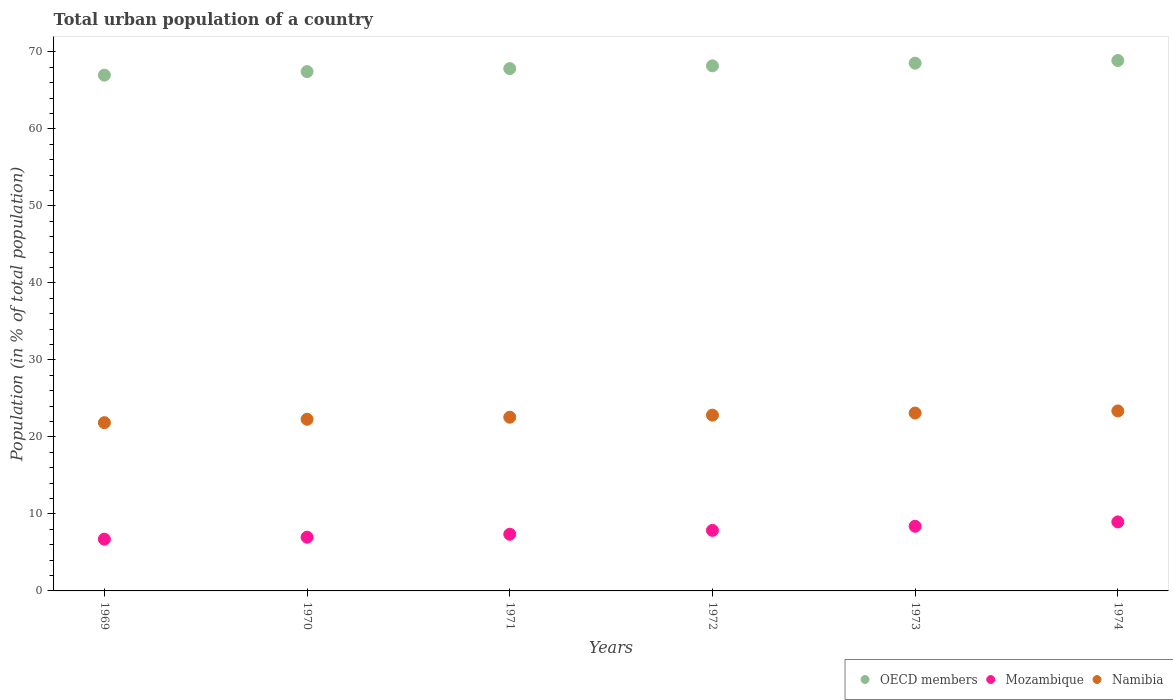How many different coloured dotlines are there?
Make the answer very short. 3. Is the number of dotlines equal to the number of legend labels?
Your answer should be compact. Yes. What is the urban population in Mozambique in 1971?
Your answer should be very brief. 7.36. Across all years, what is the maximum urban population in Namibia?
Offer a very short reply. 23.37. Across all years, what is the minimum urban population in Mozambique?
Offer a terse response. 6.72. In which year was the urban population in Namibia maximum?
Provide a succinct answer. 1974. In which year was the urban population in Namibia minimum?
Keep it short and to the point. 1969. What is the total urban population in Mozambique in the graph?
Your answer should be compact. 46.28. What is the difference between the urban population in Namibia in 1970 and that in 1974?
Offer a terse response. -1.08. What is the difference between the urban population in Mozambique in 1971 and the urban population in OECD members in 1972?
Provide a short and direct response. -60.83. What is the average urban population in OECD members per year?
Ensure brevity in your answer.  67.98. In the year 1974, what is the difference between the urban population in OECD members and urban population in Namibia?
Provide a short and direct response. 45.51. In how many years, is the urban population in Namibia greater than 48 %?
Offer a very short reply. 0. What is the ratio of the urban population in OECD members in 1969 to that in 1971?
Keep it short and to the point. 0.99. Is the urban population in Namibia in 1969 less than that in 1974?
Your answer should be very brief. Yes. What is the difference between the highest and the second highest urban population in Mozambique?
Offer a terse response. 0.57. What is the difference between the highest and the lowest urban population in Namibia?
Provide a succinct answer. 1.52. In how many years, is the urban population in Namibia greater than the average urban population in Namibia taken over all years?
Make the answer very short. 3. Does the urban population in Namibia monotonically increase over the years?
Your answer should be compact. Yes. What is the difference between two consecutive major ticks on the Y-axis?
Offer a terse response. 10. Are the values on the major ticks of Y-axis written in scientific E-notation?
Keep it short and to the point. No. Where does the legend appear in the graph?
Provide a short and direct response. Bottom right. How many legend labels are there?
Offer a terse response. 3. What is the title of the graph?
Make the answer very short. Total urban population of a country. What is the label or title of the Y-axis?
Provide a succinct answer. Population (in % of total population). What is the Population (in % of total population) of OECD members in 1969?
Provide a short and direct response. 66.98. What is the Population (in % of total population) in Mozambique in 1969?
Your answer should be very brief. 6.72. What is the Population (in % of total population) in Namibia in 1969?
Make the answer very short. 21.85. What is the Population (in % of total population) of OECD members in 1970?
Provide a short and direct response. 67.45. What is the Population (in % of total population) in Mozambique in 1970?
Your response must be concise. 6.98. What is the Population (in % of total population) in Namibia in 1970?
Your answer should be very brief. 22.29. What is the Population (in % of total population) in OECD members in 1971?
Offer a terse response. 67.84. What is the Population (in % of total population) of Mozambique in 1971?
Provide a short and direct response. 7.36. What is the Population (in % of total population) of Namibia in 1971?
Ensure brevity in your answer.  22.56. What is the Population (in % of total population) in OECD members in 1972?
Your answer should be very brief. 68.19. What is the Population (in % of total population) in Mozambique in 1972?
Ensure brevity in your answer.  7.86. What is the Population (in % of total population) of Namibia in 1972?
Keep it short and to the point. 22.83. What is the Population (in % of total population) in OECD members in 1973?
Provide a succinct answer. 68.54. What is the Population (in % of total population) in Mozambique in 1973?
Offer a terse response. 8.4. What is the Population (in % of total population) in Namibia in 1973?
Give a very brief answer. 23.1. What is the Population (in % of total population) of OECD members in 1974?
Your answer should be very brief. 68.89. What is the Population (in % of total population) in Mozambique in 1974?
Give a very brief answer. 8.96. What is the Population (in % of total population) in Namibia in 1974?
Offer a very short reply. 23.37. Across all years, what is the maximum Population (in % of total population) in OECD members?
Your response must be concise. 68.89. Across all years, what is the maximum Population (in % of total population) of Mozambique?
Ensure brevity in your answer.  8.96. Across all years, what is the maximum Population (in % of total population) in Namibia?
Your answer should be compact. 23.37. Across all years, what is the minimum Population (in % of total population) in OECD members?
Provide a short and direct response. 66.98. Across all years, what is the minimum Population (in % of total population) of Mozambique?
Make the answer very short. 6.72. Across all years, what is the minimum Population (in % of total population) in Namibia?
Provide a short and direct response. 21.85. What is the total Population (in % of total population) of OECD members in the graph?
Provide a succinct answer. 407.88. What is the total Population (in % of total population) of Mozambique in the graph?
Offer a terse response. 46.28. What is the total Population (in % of total population) in Namibia in the graph?
Your answer should be compact. 136.01. What is the difference between the Population (in % of total population) of OECD members in 1969 and that in 1970?
Your response must be concise. -0.46. What is the difference between the Population (in % of total population) of Mozambique in 1969 and that in 1970?
Offer a very short reply. -0.26. What is the difference between the Population (in % of total population) of Namibia in 1969 and that in 1970?
Your answer should be compact. -0.44. What is the difference between the Population (in % of total population) in OECD members in 1969 and that in 1971?
Keep it short and to the point. -0.85. What is the difference between the Population (in % of total population) in Mozambique in 1969 and that in 1971?
Provide a succinct answer. -0.64. What is the difference between the Population (in % of total population) in Namibia in 1969 and that in 1971?
Your response must be concise. -0.71. What is the difference between the Population (in % of total population) of OECD members in 1969 and that in 1972?
Offer a terse response. -1.21. What is the difference between the Population (in % of total population) in Mozambique in 1969 and that in 1972?
Offer a very short reply. -1.14. What is the difference between the Population (in % of total population) of Namibia in 1969 and that in 1972?
Make the answer very short. -0.98. What is the difference between the Population (in % of total population) in OECD members in 1969 and that in 1973?
Offer a very short reply. -1.55. What is the difference between the Population (in % of total population) in Mozambique in 1969 and that in 1973?
Your response must be concise. -1.68. What is the difference between the Population (in % of total population) in Namibia in 1969 and that in 1973?
Your answer should be compact. -1.25. What is the difference between the Population (in % of total population) in OECD members in 1969 and that in 1974?
Your answer should be very brief. -1.9. What is the difference between the Population (in % of total population) in Mozambique in 1969 and that in 1974?
Your answer should be compact. -2.24. What is the difference between the Population (in % of total population) of Namibia in 1969 and that in 1974?
Keep it short and to the point. -1.52. What is the difference between the Population (in % of total population) in OECD members in 1970 and that in 1971?
Your answer should be compact. -0.39. What is the difference between the Population (in % of total population) in Mozambique in 1970 and that in 1971?
Provide a short and direct response. -0.38. What is the difference between the Population (in % of total population) of Namibia in 1970 and that in 1971?
Your response must be concise. -0.27. What is the difference between the Population (in % of total population) in OECD members in 1970 and that in 1972?
Your answer should be very brief. -0.75. What is the difference between the Population (in % of total population) of Mozambique in 1970 and that in 1972?
Keep it short and to the point. -0.89. What is the difference between the Population (in % of total population) in Namibia in 1970 and that in 1972?
Give a very brief answer. -0.54. What is the difference between the Population (in % of total population) of OECD members in 1970 and that in 1973?
Your answer should be very brief. -1.09. What is the difference between the Population (in % of total population) in Mozambique in 1970 and that in 1973?
Offer a very short reply. -1.42. What is the difference between the Population (in % of total population) of Namibia in 1970 and that in 1973?
Your response must be concise. -0.81. What is the difference between the Population (in % of total population) in OECD members in 1970 and that in 1974?
Your response must be concise. -1.44. What is the difference between the Population (in % of total population) in Mozambique in 1970 and that in 1974?
Your answer should be compact. -1.98. What is the difference between the Population (in % of total population) of Namibia in 1970 and that in 1974?
Keep it short and to the point. -1.08. What is the difference between the Population (in % of total population) of OECD members in 1971 and that in 1972?
Your answer should be very brief. -0.36. What is the difference between the Population (in % of total population) of Mozambique in 1971 and that in 1972?
Offer a terse response. -0.5. What is the difference between the Population (in % of total population) of Namibia in 1971 and that in 1972?
Make the answer very short. -0.27. What is the difference between the Population (in % of total population) of OECD members in 1971 and that in 1973?
Offer a very short reply. -0.7. What is the difference between the Population (in % of total population) in Mozambique in 1971 and that in 1973?
Your response must be concise. -1.04. What is the difference between the Population (in % of total population) of Namibia in 1971 and that in 1973?
Make the answer very short. -0.54. What is the difference between the Population (in % of total population) of OECD members in 1971 and that in 1974?
Provide a short and direct response. -1.05. What is the difference between the Population (in % of total population) of Mozambique in 1971 and that in 1974?
Ensure brevity in your answer.  -1.6. What is the difference between the Population (in % of total population) in Namibia in 1971 and that in 1974?
Offer a very short reply. -0.81. What is the difference between the Population (in % of total population) in OECD members in 1972 and that in 1973?
Your answer should be very brief. -0.34. What is the difference between the Population (in % of total population) in Mozambique in 1972 and that in 1973?
Your answer should be compact. -0.53. What is the difference between the Population (in % of total population) of Namibia in 1972 and that in 1973?
Your response must be concise. -0.27. What is the difference between the Population (in % of total population) in OECD members in 1972 and that in 1974?
Your answer should be compact. -0.69. What is the difference between the Population (in % of total population) in Mozambique in 1972 and that in 1974?
Offer a very short reply. -1.1. What is the difference between the Population (in % of total population) in Namibia in 1972 and that in 1974?
Give a very brief answer. -0.55. What is the difference between the Population (in % of total population) of OECD members in 1973 and that in 1974?
Provide a succinct answer. -0.35. What is the difference between the Population (in % of total population) of Mozambique in 1973 and that in 1974?
Provide a succinct answer. -0.57. What is the difference between the Population (in % of total population) in Namibia in 1973 and that in 1974?
Your answer should be very brief. -0.27. What is the difference between the Population (in % of total population) of OECD members in 1969 and the Population (in % of total population) of Mozambique in 1970?
Give a very brief answer. 60.01. What is the difference between the Population (in % of total population) in OECD members in 1969 and the Population (in % of total population) in Namibia in 1970?
Make the answer very short. 44.69. What is the difference between the Population (in % of total population) of Mozambique in 1969 and the Population (in % of total population) of Namibia in 1970?
Give a very brief answer. -15.57. What is the difference between the Population (in % of total population) in OECD members in 1969 and the Population (in % of total population) in Mozambique in 1971?
Offer a terse response. 59.62. What is the difference between the Population (in % of total population) in OECD members in 1969 and the Population (in % of total population) in Namibia in 1971?
Offer a terse response. 44.43. What is the difference between the Population (in % of total population) in Mozambique in 1969 and the Population (in % of total population) in Namibia in 1971?
Offer a terse response. -15.84. What is the difference between the Population (in % of total population) of OECD members in 1969 and the Population (in % of total population) of Mozambique in 1972?
Your response must be concise. 59.12. What is the difference between the Population (in % of total population) in OECD members in 1969 and the Population (in % of total population) in Namibia in 1972?
Provide a short and direct response. 44.16. What is the difference between the Population (in % of total population) in Mozambique in 1969 and the Population (in % of total population) in Namibia in 1972?
Provide a short and direct response. -16.11. What is the difference between the Population (in % of total population) of OECD members in 1969 and the Population (in % of total population) of Mozambique in 1973?
Give a very brief answer. 58.59. What is the difference between the Population (in % of total population) in OECD members in 1969 and the Population (in % of total population) in Namibia in 1973?
Make the answer very short. 43.88. What is the difference between the Population (in % of total population) of Mozambique in 1969 and the Population (in % of total population) of Namibia in 1973?
Offer a very short reply. -16.38. What is the difference between the Population (in % of total population) in OECD members in 1969 and the Population (in % of total population) in Mozambique in 1974?
Your answer should be compact. 58.02. What is the difference between the Population (in % of total population) in OECD members in 1969 and the Population (in % of total population) in Namibia in 1974?
Give a very brief answer. 43.61. What is the difference between the Population (in % of total population) of Mozambique in 1969 and the Population (in % of total population) of Namibia in 1974?
Your answer should be very brief. -16.65. What is the difference between the Population (in % of total population) in OECD members in 1970 and the Population (in % of total population) in Mozambique in 1971?
Your answer should be very brief. 60.08. What is the difference between the Population (in % of total population) in OECD members in 1970 and the Population (in % of total population) in Namibia in 1971?
Make the answer very short. 44.89. What is the difference between the Population (in % of total population) in Mozambique in 1970 and the Population (in % of total population) in Namibia in 1971?
Your answer should be compact. -15.58. What is the difference between the Population (in % of total population) in OECD members in 1970 and the Population (in % of total population) in Mozambique in 1972?
Make the answer very short. 59.58. What is the difference between the Population (in % of total population) of OECD members in 1970 and the Population (in % of total population) of Namibia in 1972?
Your answer should be compact. 44.62. What is the difference between the Population (in % of total population) of Mozambique in 1970 and the Population (in % of total population) of Namibia in 1972?
Provide a short and direct response. -15.85. What is the difference between the Population (in % of total population) of OECD members in 1970 and the Population (in % of total population) of Mozambique in 1973?
Ensure brevity in your answer.  59.05. What is the difference between the Population (in % of total population) in OECD members in 1970 and the Population (in % of total population) in Namibia in 1973?
Offer a terse response. 44.35. What is the difference between the Population (in % of total population) in Mozambique in 1970 and the Population (in % of total population) in Namibia in 1973?
Ensure brevity in your answer.  -16.12. What is the difference between the Population (in % of total population) of OECD members in 1970 and the Population (in % of total population) of Mozambique in 1974?
Ensure brevity in your answer.  58.48. What is the difference between the Population (in % of total population) of OECD members in 1970 and the Population (in % of total population) of Namibia in 1974?
Give a very brief answer. 44.07. What is the difference between the Population (in % of total population) in Mozambique in 1970 and the Population (in % of total population) in Namibia in 1974?
Give a very brief answer. -16.39. What is the difference between the Population (in % of total population) of OECD members in 1971 and the Population (in % of total population) of Mozambique in 1972?
Provide a short and direct response. 59.97. What is the difference between the Population (in % of total population) in OECD members in 1971 and the Population (in % of total population) in Namibia in 1972?
Provide a succinct answer. 45.01. What is the difference between the Population (in % of total population) of Mozambique in 1971 and the Population (in % of total population) of Namibia in 1972?
Provide a succinct answer. -15.47. What is the difference between the Population (in % of total population) of OECD members in 1971 and the Population (in % of total population) of Mozambique in 1973?
Keep it short and to the point. 59.44. What is the difference between the Population (in % of total population) of OECD members in 1971 and the Population (in % of total population) of Namibia in 1973?
Your answer should be compact. 44.74. What is the difference between the Population (in % of total population) of Mozambique in 1971 and the Population (in % of total population) of Namibia in 1973?
Make the answer very short. -15.74. What is the difference between the Population (in % of total population) of OECD members in 1971 and the Population (in % of total population) of Mozambique in 1974?
Provide a succinct answer. 58.87. What is the difference between the Population (in % of total population) of OECD members in 1971 and the Population (in % of total population) of Namibia in 1974?
Your answer should be compact. 44.46. What is the difference between the Population (in % of total population) in Mozambique in 1971 and the Population (in % of total population) in Namibia in 1974?
Provide a short and direct response. -16.01. What is the difference between the Population (in % of total population) in OECD members in 1972 and the Population (in % of total population) in Mozambique in 1973?
Make the answer very short. 59.8. What is the difference between the Population (in % of total population) of OECD members in 1972 and the Population (in % of total population) of Namibia in 1973?
Ensure brevity in your answer.  45.09. What is the difference between the Population (in % of total population) of Mozambique in 1972 and the Population (in % of total population) of Namibia in 1973?
Make the answer very short. -15.24. What is the difference between the Population (in % of total population) of OECD members in 1972 and the Population (in % of total population) of Mozambique in 1974?
Give a very brief answer. 59.23. What is the difference between the Population (in % of total population) of OECD members in 1972 and the Population (in % of total population) of Namibia in 1974?
Provide a succinct answer. 44.82. What is the difference between the Population (in % of total population) in Mozambique in 1972 and the Population (in % of total population) in Namibia in 1974?
Offer a terse response. -15.51. What is the difference between the Population (in % of total population) of OECD members in 1973 and the Population (in % of total population) of Mozambique in 1974?
Your answer should be compact. 59.57. What is the difference between the Population (in % of total population) in OECD members in 1973 and the Population (in % of total population) in Namibia in 1974?
Ensure brevity in your answer.  45.16. What is the difference between the Population (in % of total population) of Mozambique in 1973 and the Population (in % of total population) of Namibia in 1974?
Your answer should be compact. -14.98. What is the average Population (in % of total population) of OECD members per year?
Keep it short and to the point. 67.98. What is the average Population (in % of total population) in Mozambique per year?
Your answer should be very brief. 7.71. What is the average Population (in % of total population) of Namibia per year?
Offer a terse response. 22.67. In the year 1969, what is the difference between the Population (in % of total population) in OECD members and Population (in % of total population) in Mozambique?
Provide a succinct answer. 60.26. In the year 1969, what is the difference between the Population (in % of total population) in OECD members and Population (in % of total population) in Namibia?
Your answer should be very brief. 45.13. In the year 1969, what is the difference between the Population (in % of total population) of Mozambique and Population (in % of total population) of Namibia?
Make the answer very short. -15.13. In the year 1970, what is the difference between the Population (in % of total population) of OECD members and Population (in % of total population) of Mozambique?
Ensure brevity in your answer.  60.47. In the year 1970, what is the difference between the Population (in % of total population) in OECD members and Population (in % of total population) in Namibia?
Provide a succinct answer. 45.15. In the year 1970, what is the difference between the Population (in % of total population) in Mozambique and Population (in % of total population) in Namibia?
Your answer should be very brief. -15.31. In the year 1971, what is the difference between the Population (in % of total population) of OECD members and Population (in % of total population) of Mozambique?
Offer a very short reply. 60.47. In the year 1971, what is the difference between the Population (in % of total population) of OECD members and Population (in % of total population) of Namibia?
Offer a very short reply. 45.28. In the year 1971, what is the difference between the Population (in % of total population) in Mozambique and Population (in % of total population) in Namibia?
Give a very brief answer. -15.2. In the year 1972, what is the difference between the Population (in % of total population) of OECD members and Population (in % of total population) of Mozambique?
Your answer should be compact. 60.33. In the year 1972, what is the difference between the Population (in % of total population) of OECD members and Population (in % of total population) of Namibia?
Your answer should be compact. 45.36. In the year 1972, what is the difference between the Population (in % of total population) in Mozambique and Population (in % of total population) in Namibia?
Your answer should be very brief. -14.96. In the year 1973, what is the difference between the Population (in % of total population) in OECD members and Population (in % of total population) in Mozambique?
Your response must be concise. 60.14. In the year 1973, what is the difference between the Population (in % of total population) in OECD members and Population (in % of total population) in Namibia?
Provide a succinct answer. 45.44. In the year 1973, what is the difference between the Population (in % of total population) of Mozambique and Population (in % of total population) of Namibia?
Offer a terse response. -14.7. In the year 1974, what is the difference between the Population (in % of total population) of OECD members and Population (in % of total population) of Mozambique?
Provide a succinct answer. 59.92. In the year 1974, what is the difference between the Population (in % of total population) in OECD members and Population (in % of total population) in Namibia?
Make the answer very short. 45.51. In the year 1974, what is the difference between the Population (in % of total population) in Mozambique and Population (in % of total population) in Namibia?
Provide a short and direct response. -14.41. What is the ratio of the Population (in % of total population) in OECD members in 1969 to that in 1970?
Your answer should be compact. 0.99. What is the ratio of the Population (in % of total population) of Mozambique in 1969 to that in 1970?
Provide a succinct answer. 0.96. What is the ratio of the Population (in % of total population) of Namibia in 1969 to that in 1970?
Make the answer very short. 0.98. What is the ratio of the Population (in % of total population) of OECD members in 1969 to that in 1971?
Provide a short and direct response. 0.99. What is the ratio of the Population (in % of total population) in Mozambique in 1969 to that in 1971?
Your response must be concise. 0.91. What is the ratio of the Population (in % of total population) of Namibia in 1969 to that in 1971?
Offer a terse response. 0.97. What is the ratio of the Population (in % of total population) in OECD members in 1969 to that in 1972?
Your answer should be compact. 0.98. What is the ratio of the Population (in % of total population) of Mozambique in 1969 to that in 1972?
Offer a very short reply. 0.85. What is the ratio of the Population (in % of total population) of Namibia in 1969 to that in 1972?
Ensure brevity in your answer.  0.96. What is the ratio of the Population (in % of total population) in OECD members in 1969 to that in 1973?
Ensure brevity in your answer.  0.98. What is the ratio of the Population (in % of total population) in Mozambique in 1969 to that in 1973?
Make the answer very short. 0.8. What is the ratio of the Population (in % of total population) of Namibia in 1969 to that in 1973?
Keep it short and to the point. 0.95. What is the ratio of the Population (in % of total population) in OECD members in 1969 to that in 1974?
Provide a short and direct response. 0.97. What is the ratio of the Population (in % of total population) of Mozambique in 1969 to that in 1974?
Your response must be concise. 0.75. What is the ratio of the Population (in % of total population) in Namibia in 1969 to that in 1974?
Offer a terse response. 0.93. What is the ratio of the Population (in % of total population) of OECD members in 1970 to that in 1971?
Make the answer very short. 0.99. What is the ratio of the Population (in % of total population) in Mozambique in 1970 to that in 1971?
Provide a short and direct response. 0.95. What is the ratio of the Population (in % of total population) in Namibia in 1970 to that in 1971?
Provide a short and direct response. 0.99. What is the ratio of the Population (in % of total population) of Mozambique in 1970 to that in 1972?
Provide a short and direct response. 0.89. What is the ratio of the Population (in % of total population) of Namibia in 1970 to that in 1972?
Offer a very short reply. 0.98. What is the ratio of the Population (in % of total population) of OECD members in 1970 to that in 1973?
Your answer should be compact. 0.98. What is the ratio of the Population (in % of total population) of Mozambique in 1970 to that in 1973?
Your response must be concise. 0.83. What is the ratio of the Population (in % of total population) of Namibia in 1970 to that in 1973?
Make the answer very short. 0.96. What is the ratio of the Population (in % of total population) of OECD members in 1970 to that in 1974?
Ensure brevity in your answer.  0.98. What is the ratio of the Population (in % of total population) of Mozambique in 1970 to that in 1974?
Provide a short and direct response. 0.78. What is the ratio of the Population (in % of total population) in Namibia in 1970 to that in 1974?
Offer a terse response. 0.95. What is the ratio of the Population (in % of total population) of Mozambique in 1971 to that in 1972?
Provide a short and direct response. 0.94. What is the ratio of the Population (in % of total population) of Namibia in 1971 to that in 1972?
Ensure brevity in your answer.  0.99. What is the ratio of the Population (in % of total population) in OECD members in 1971 to that in 1973?
Ensure brevity in your answer.  0.99. What is the ratio of the Population (in % of total population) of Mozambique in 1971 to that in 1973?
Offer a very short reply. 0.88. What is the ratio of the Population (in % of total population) of Namibia in 1971 to that in 1973?
Make the answer very short. 0.98. What is the ratio of the Population (in % of total population) in OECD members in 1971 to that in 1974?
Your answer should be compact. 0.98. What is the ratio of the Population (in % of total population) of Mozambique in 1971 to that in 1974?
Provide a succinct answer. 0.82. What is the ratio of the Population (in % of total population) in Namibia in 1971 to that in 1974?
Your answer should be compact. 0.97. What is the ratio of the Population (in % of total population) in OECD members in 1972 to that in 1973?
Offer a very short reply. 0.99. What is the ratio of the Population (in % of total population) of Mozambique in 1972 to that in 1973?
Offer a very short reply. 0.94. What is the ratio of the Population (in % of total population) of Namibia in 1972 to that in 1973?
Your response must be concise. 0.99. What is the ratio of the Population (in % of total population) in OECD members in 1972 to that in 1974?
Your answer should be very brief. 0.99. What is the ratio of the Population (in % of total population) in Mozambique in 1972 to that in 1974?
Offer a terse response. 0.88. What is the ratio of the Population (in % of total population) of Namibia in 1972 to that in 1974?
Provide a short and direct response. 0.98. What is the ratio of the Population (in % of total population) in Mozambique in 1973 to that in 1974?
Offer a terse response. 0.94. What is the ratio of the Population (in % of total population) in Namibia in 1973 to that in 1974?
Keep it short and to the point. 0.99. What is the difference between the highest and the second highest Population (in % of total population) of OECD members?
Provide a short and direct response. 0.35. What is the difference between the highest and the second highest Population (in % of total population) of Mozambique?
Provide a short and direct response. 0.57. What is the difference between the highest and the second highest Population (in % of total population) in Namibia?
Make the answer very short. 0.27. What is the difference between the highest and the lowest Population (in % of total population) in OECD members?
Your answer should be very brief. 1.9. What is the difference between the highest and the lowest Population (in % of total population) in Mozambique?
Give a very brief answer. 2.24. What is the difference between the highest and the lowest Population (in % of total population) of Namibia?
Make the answer very short. 1.52. 